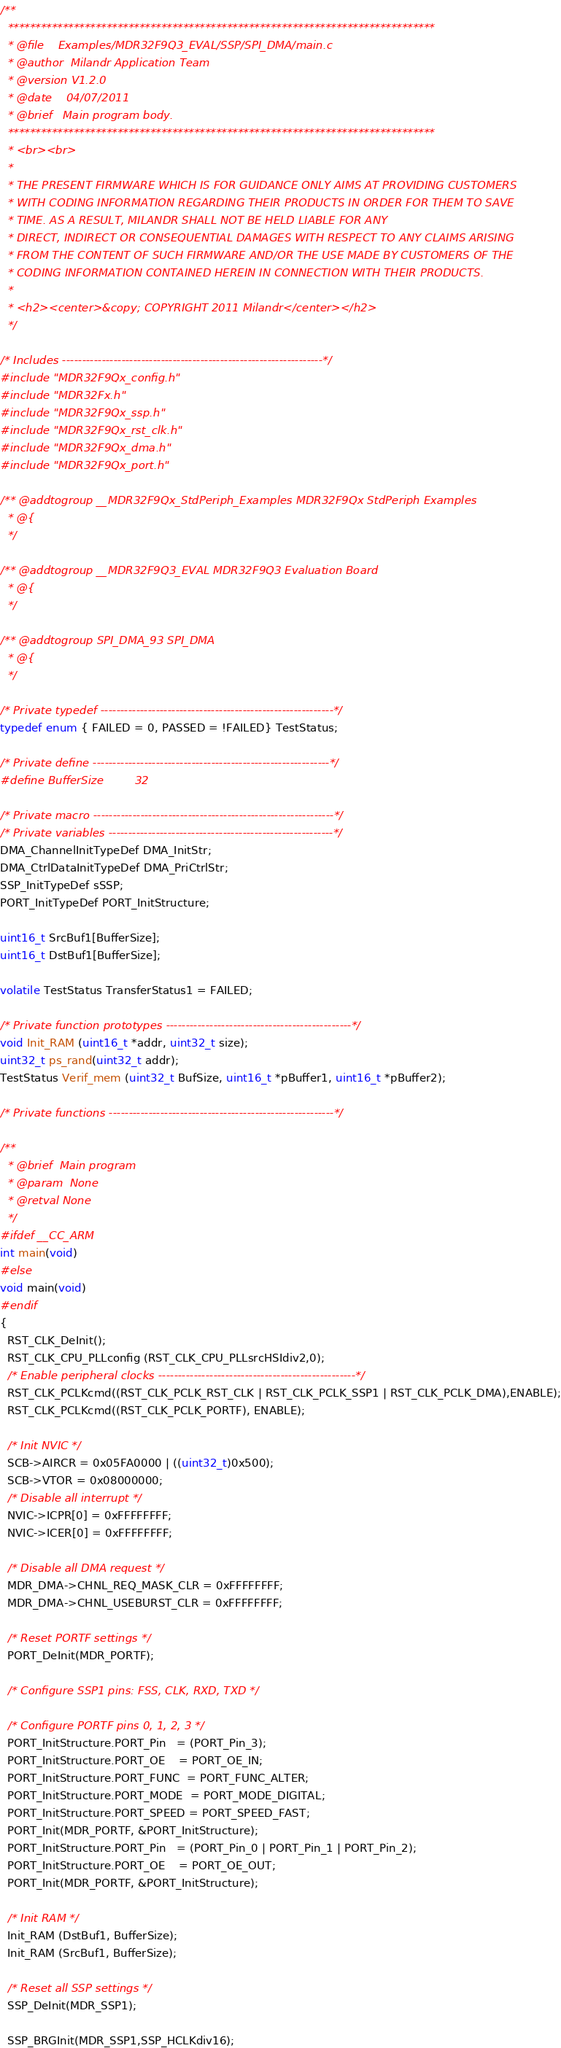Convert code to text. <code><loc_0><loc_0><loc_500><loc_500><_C_>/**
  ******************************************************************************
  * @file    Examples/MDR32F9Q3_EVAL/SSP/SPI_DMA/main.c
  * @author  Milandr Application Team
  * @version V1.2.0
  * @date    04/07/2011
  * @brief   Main program body.
  ******************************************************************************
  * <br><br>
  *
  * THE PRESENT FIRMWARE WHICH IS FOR GUIDANCE ONLY AIMS AT PROVIDING CUSTOMERS
  * WITH CODING INFORMATION REGARDING THEIR PRODUCTS IN ORDER FOR THEM TO SAVE
  * TIME. AS A RESULT, MILANDR SHALL NOT BE HELD LIABLE FOR ANY
  * DIRECT, INDIRECT OR CONSEQUENTIAL DAMAGES WITH RESPECT TO ANY CLAIMS ARISING
  * FROM THE CONTENT OF SUCH FIRMWARE AND/OR THE USE MADE BY CUSTOMERS OF THE
  * CODING INFORMATION CONTAINED HEREIN IN CONNECTION WITH THEIR PRODUCTS.
  *
  * <h2><center>&copy; COPYRIGHT 2011 Milandr</center></h2>
  */

/* Includes ------------------------------------------------------------------*/
#include "MDR32F9Qx_config.h"
#include "MDR32Fx.h"
#include "MDR32F9Qx_ssp.h"
#include "MDR32F9Qx_rst_clk.h"
#include "MDR32F9Qx_dma.h"
#include "MDR32F9Qx_port.h"

/** @addtogroup __MDR32F9Qx_StdPeriph_Examples MDR32F9Qx StdPeriph Examples
  * @{
  */

/** @addtogroup __MDR32F9Q3_EVAL MDR32F9Q3 Evaluation Board
  * @{
  */

/** @addtogroup SPI_DMA_93 SPI_DMA
  * @{
  */

/* Private typedef -----------------------------------------------------------*/
typedef enum { FAILED = 0, PASSED = !FAILED} TestStatus;

/* Private define ------------------------------------------------------------*/
#define BufferSize         32

/* Private macro -------------------------------------------------------------*/
/* Private variables ---------------------------------------------------------*/
DMA_ChannelInitTypeDef DMA_InitStr;
DMA_CtrlDataInitTypeDef DMA_PriCtrlStr;
SSP_InitTypeDef sSSP;
PORT_InitTypeDef PORT_InitStructure;

uint16_t SrcBuf1[BufferSize];
uint16_t DstBuf1[BufferSize];

volatile TestStatus TransferStatus1 = FAILED;

/* Private function prototypes -----------------------------------------------*/
void Init_RAM (uint16_t *addr, uint32_t size);
uint32_t ps_rand(uint32_t addr);
TestStatus Verif_mem (uint32_t BufSize, uint16_t *pBuffer1, uint16_t *pBuffer2);

/* Private functions ---------------------------------------------------------*/

/**
  * @brief  Main program
  * @param  None
  * @retval None
  */
#ifdef __CC_ARM
int main(void)
#else
void main(void)
#endif
{
  RST_CLK_DeInit();
  RST_CLK_CPU_PLLconfig (RST_CLK_CPU_PLLsrcHSIdiv2,0);
  /* Enable peripheral clocks --------------------------------------------------*/
  RST_CLK_PCLKcmd((RST_CLK_PCLK_RST_CLK | RST_CLK_PCLK_SSP1 | RST_CLK_PCLK_DMA),ENABLE);
  RST_CLK_PCLKcmd((RST_CLK_PCLK_PORTF), ENABLE);

  /* Init NVIC */
  SCB->AIRCR = 0x05FA0000 | ((uint32_t)0x500);
  SCB->VTOR = 0x08000000;
  /* Disable all interrupt */
  NVIC->ICPR[0] = 0xFFFFFFFF;
  NVIC->ICER[0] = 0xFFFFFFFF;

  /* Disable all DMA request */
  MDR_DMA->CHNL_REQ_MASK_CLR = 0xFFFFFFFF;
  MDR_DMA->CHNL_USEBURST_CLR = 0xFFFFFFFF;

  /* Reset PORTF settings */
  PORT_DeInit(MDR_PORTF);

  /* Configure SSP1 pins: FSS, CLK, RXD, TXD */

  /* Configure PORTF pins 0, 1, 2, 3 */
  PORT_InitStructure.PORT_Pin   = (PORT_Pin_3);
  PORT_InitStructure.PORT_OE    = PORT_OE_IN;
  PORT_InitStructure.PORT_FUNC  = PORT_FUNC_ALTER;
  PORT_InitStructure.PORT_MODE  = PORT_MODE_DIGITAL;
  PORT_InitStructure.PORT_SPEED = PORT_SPEED_FAST;
  PORT_Init(MDR_PORTF, &PORT_InitStructure);
  PORT_InitStructure.PORT_Pin   = (PORT_Pin_0 | PORT_Pin_1 | PORT_Pin_2);
  PORT_InitStructure.PORT_OE    = PORT_OE_OUT;
  PORT_Init(MDR_PORTF, &PORT_InitStructure);

  /* Init RAM */
  Init_RAM (DstBuf1, BufferSize);
  Init_RAM (SrcBuf1, BufferSize);

  /* Reset all SSP settings */
  SSP_DeInit(MDR_SSP1);

  SSP_BRGInit(MDR_SSP1,SSP_HCLKdiv16);
</code> 